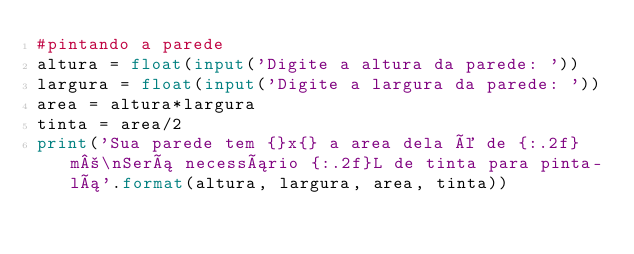Convert code to text. <code><loc_0><loc_0><loc_500><loc_500><_Python_>#pintando a parede
altura = float(input('Digite a altura da parede: '))
largura = float(input('Digite a largura da parede: '))
area = altura*largura
tinta = area/2
print('Sua parede tem {}x{} a area dela é de {:.2f}m²\nSerá necessário {:.2f}L de tinta para pinta-lá'.format(altura, largura, area, tinta))

</code> 